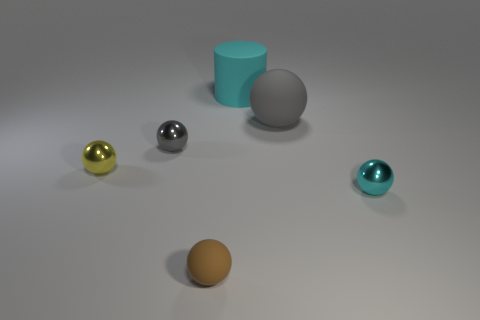Is the cyan metallic thing the same shape as the yellow metallic object?
Provide a short and direct response. Yes. How many tiny things are either gray metal objects or metal spheres?
Your answer should be very brief. 3. There is a yellow metal object; are there any small yellow metallic things to the left of it?
Offer a terse response. No. Are there an equal number of big cyan cylinders left of the small brown matte thing and brown metal balls?
Provide a succinct answer. Yes. There is a cyan metal thing that is the same shape as the gray rubber object; what is its size?
Ensure brevity in your answer.  Small. Is the shape of the small yellow object the same as the cyan object that is behind the cyan metallic ball?
Keep it short and to the point. No. There is a matte ball that is in front of the tiny metallic thing to the left of the gray metal sphere; what is its size?
Make the answer very short. Small. Are there the same number of shiny spheres behind the cyan matte thing and tiny metal balls behind the yellow metallic sphere?
Your answer should be very brief. No. The large thing that is the same shape as the small gray object is what color?
Make the answer very short. Gray. What number of other spheres have the same color as the big ball?
Provide a succinct answer. 1. 